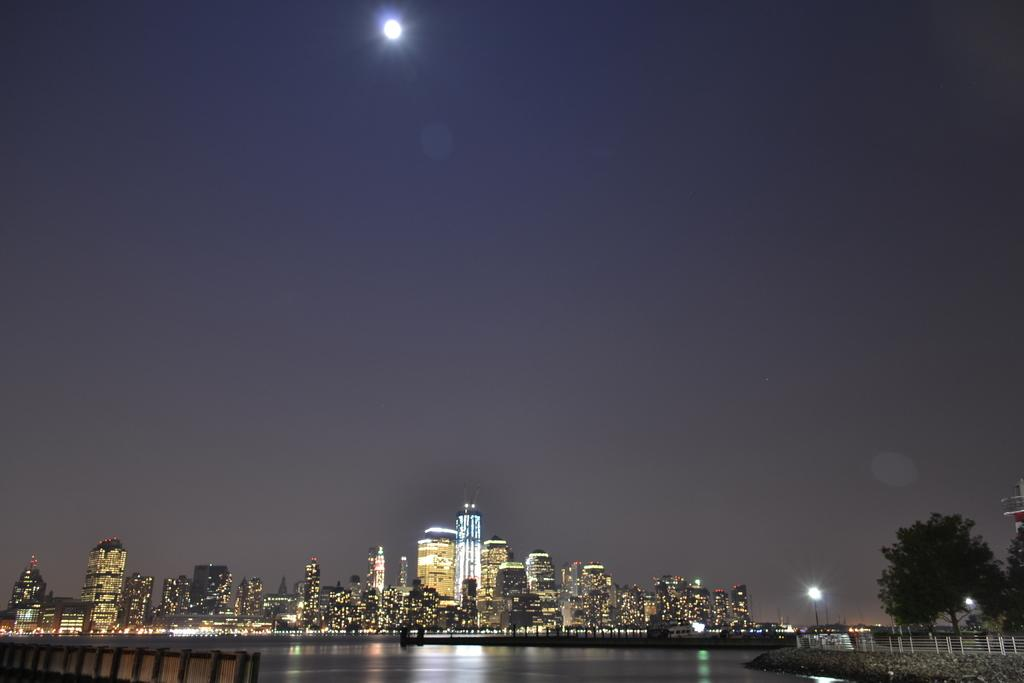What type of structures can be seen in the image? There are fences, buildings, and trees visible in the image. What natural element is present in the image? There is water visible in the image. Are there any artificial light sources in the image? Yes, there are lights in the image. What else can be seen in the image besides the mentioned elements? There are some objects in the image. What is visible in the background of the image? The sky is visible in the background of the image. What type of brass instrument is being played in the image? There is no brass instrument or any musical instrument present in the image. How many people are lifting heavy objects in the image? There is no one lifting heavy objects in the image. 